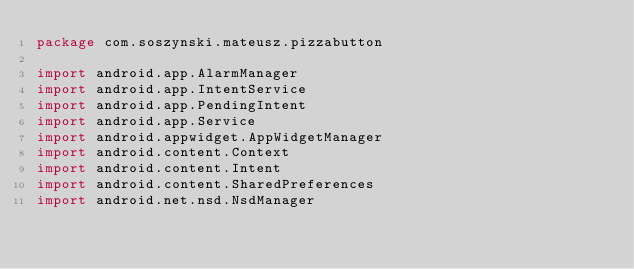<code> <loc_0><loc_0><loc_500><loc_500><_Kotlin_>package com.soszynski.mateusz.pizzabutton

import android.app.AlarmManager
import android.app.IntentService
import android.app.PendingIntent
import android.app.Service
import android.appwidget.AppWidgetManager
import android.content.Context
import android.content.Intent
import android.content.SharedPreferences
import android.net.nsd.NsdManager</code> 